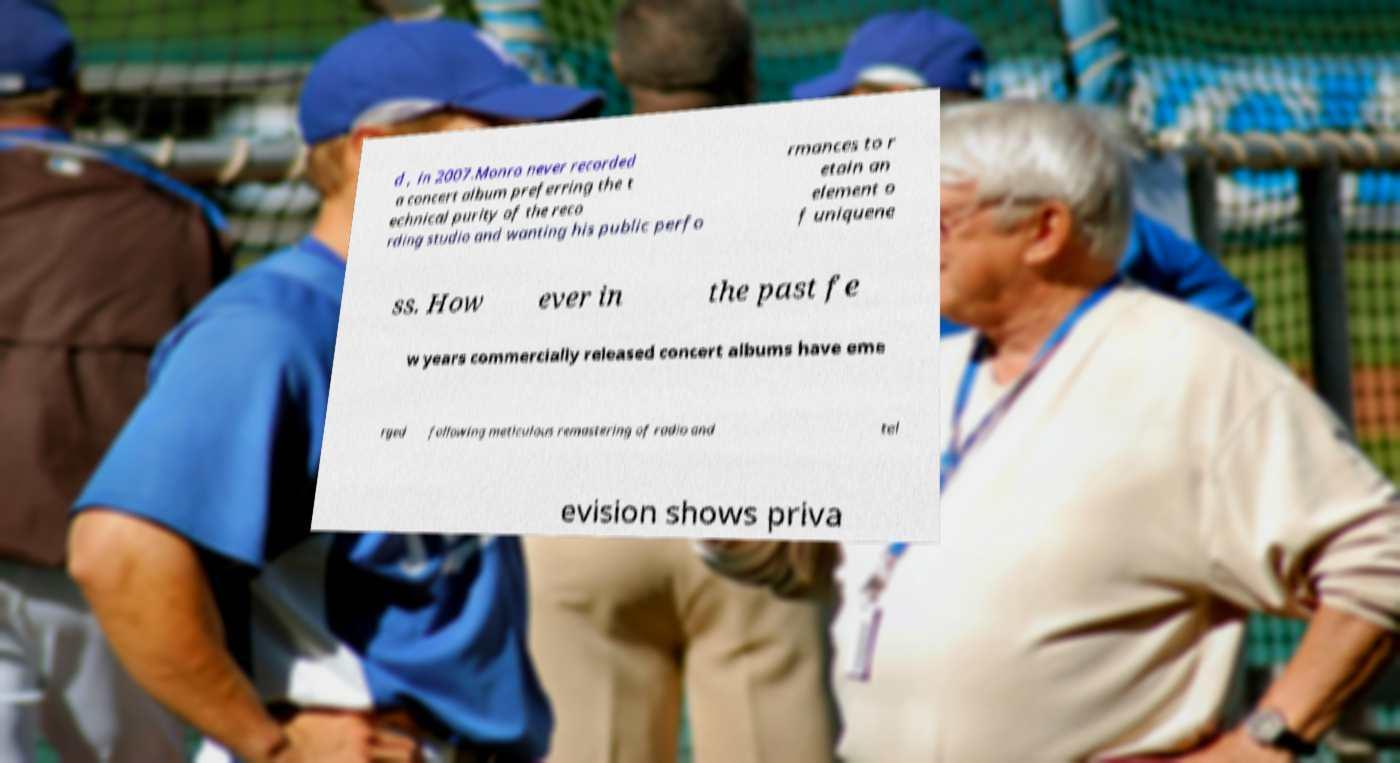Please identify and transcribe the text found in this image. d , in 2007.Monro never recorded a concert album preferring the t echnical purity of the reco rding studio and wanting his public perfo rmances to r etain an element o f uniquene ss. How ever in the past fe w years commercially released concert albums have eme rged following meticulous remastering of radio and tel evision shows priva 